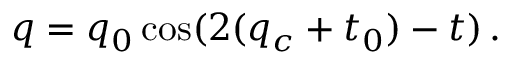<formula> <loc_0><loc_0><loc_500><loc_500>q = q _ { 0 } \cos ( 2 ( q _ { c } + t _ { 0 } ) - t ) \, .</formula> 